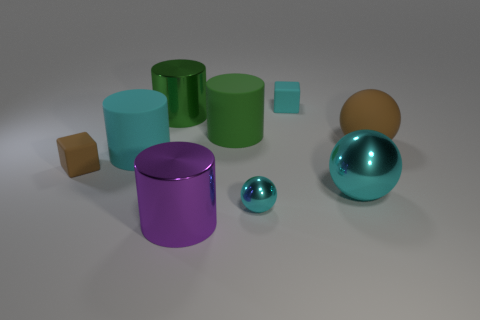There is a big object that is in front of the small brown block and left of the cyan cube; what is it made of?
Your answer should be very brief. Metal. There is a metallic object that is right of the cyan thing behind the cyan cylinder; what is its color?
Keep it short and to the point. Cyan. There is a large cyan object in front of the tiny brown block; what is it made of?
Make the answer very short. Metal. Are there fewer green objects than yellow balls?
Offer a very short reply. No. Does the big green metallic thing have the same shape as the brown thing in front of the brown rubber ball?
Ensure brevity in your answer.  No. What is the shape of the cyan object that is both in front of the big brown matte ball and behind the big cyan ball?
Offer a very short reply. Cylinder. Is the number of brown balls that are behind the green shiny thing the same as the number of large rubber objects on the left side of the large green matte thing?
Keep it short and to the point. No. There is a big metallic thing behind the large cyan metal sphere; is it the same shape as the big brown matte object?
Offer a very short reply. No. What number of brown objects are either cylinders or matte objects?
Ensure brevity in your answer.  2. There is a small cyan object that is the same shape as the big brown rubber thing; what material is it?
Ensure brevity in your answer.  Metal. 